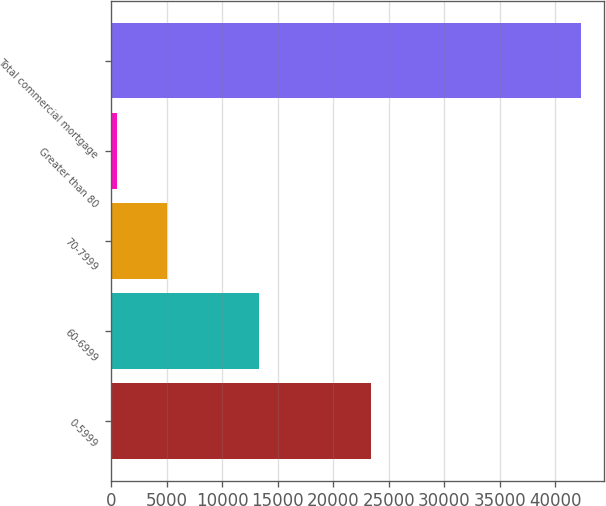Convert chart. <chart><loc_0><loc_0><loc_500><loc_500><bar_chart><fcel>0-5999<fcel>60-6999<fcel>70-7999<fcel>Greater than 80<fcel>Total commercial mortgage<nl><fcel>23401<fcel>13300<fcel>5039<fcel>563<fcel>42303<nl></chart> 